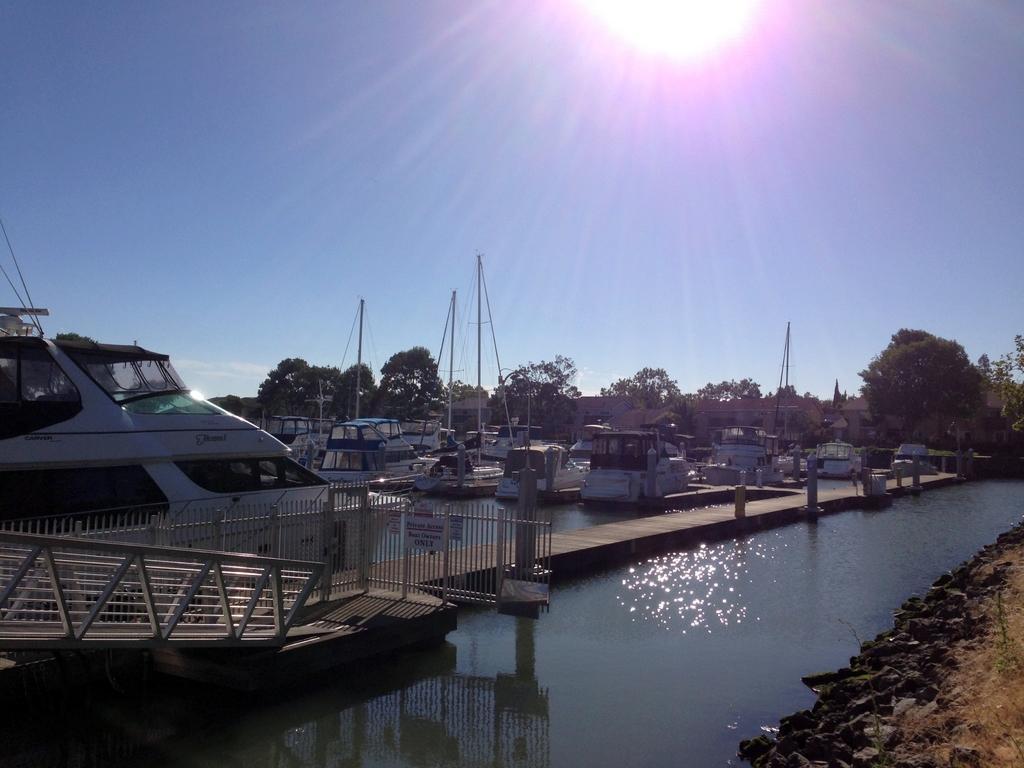Describe this image in one or two sentences. In this image we can see ships at the deck, river, trees, poles, sky, stones, ground and sun. 